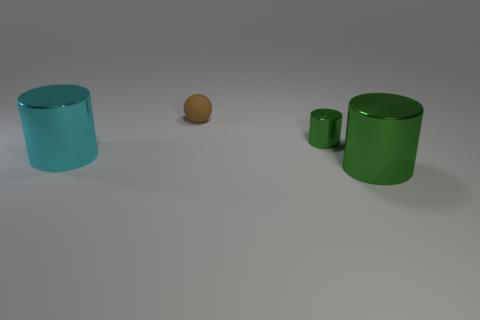Add 3 big brown shiny cylinders. How many objects exist? 7 Subtract all balls. How many objects are left? 3 Add 2 cylinders. How many cylinders exist? 5 Subtract 0 gray spheres. How many objects are left? 4 Subtract all green metal cylinders. Subtract all large cyan shiny objects. How many objects are left? 1 Add 3 cyan shiny cylinders. How many cyan shiny cylinders are left? 4 